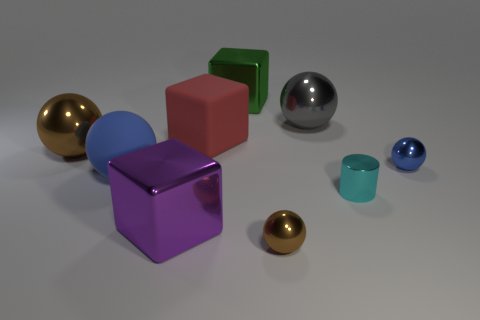Is there a particular theme or concept that the arrangement of these objects might represent? The arrangement of objects might suggest a few themes. One could view it as a study in geometry and color, with each object showcasing a distinct shape and shade. Alternatively, one might see it as a metaphor for diversity and individuality, with each piece standing unique yet part of a larger ensemble. The varying reflections and luminance could also represent the concept of perspective and how viewpoints can change the perception of an item's color and texture. 